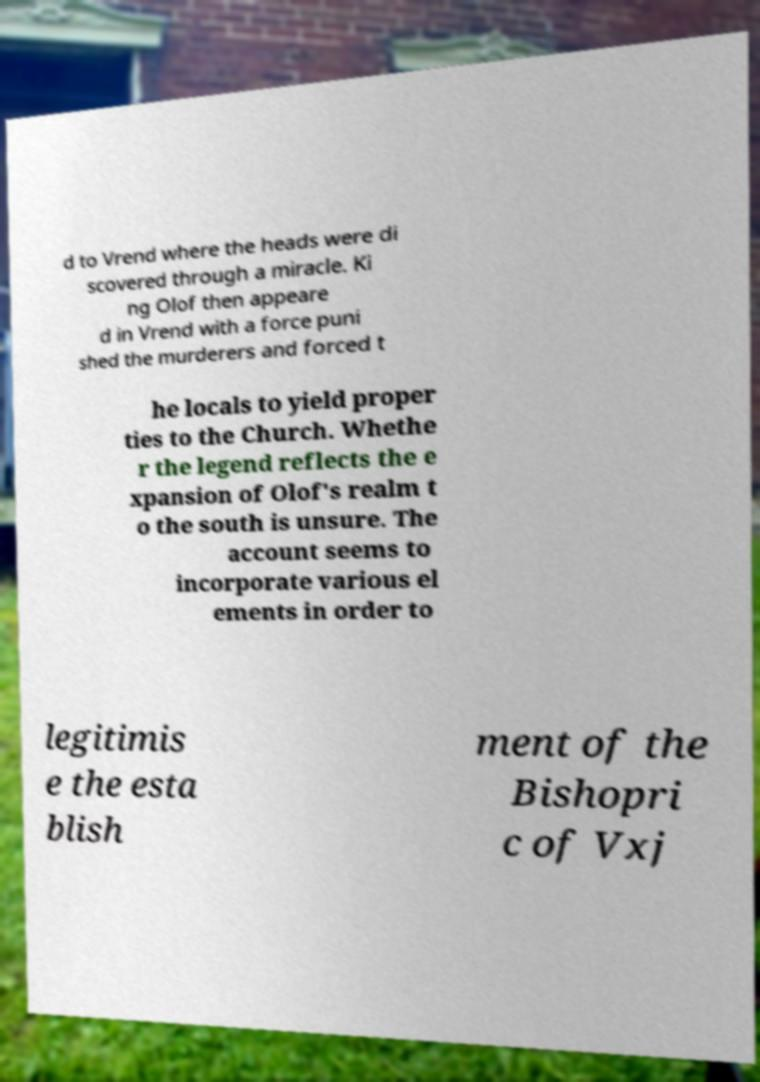I need the written content from this picture converted into text. Can you do that? d to Vrend where the heads were di scovered through a miracle. Ki ng Olof then appeare d in Vrend with a force puni shed the murderers and forced t he locals to yield proper ties to the Church. Whethe r the legend reflects the e xpansion of Olof's realm t o the south is unsure. The account seems to incorporate various el ements in order to legitimis e the esta blish ment of the Bishopri c of Vxj 